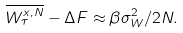<formula> <loc_0><loc_0><loc_500><loc_500>\overline { W _ { \tau } ^ { x , N } } - \Delta F \approx \beta \sigma _ { W } ^ { 2 } / 2 N .</formula> 